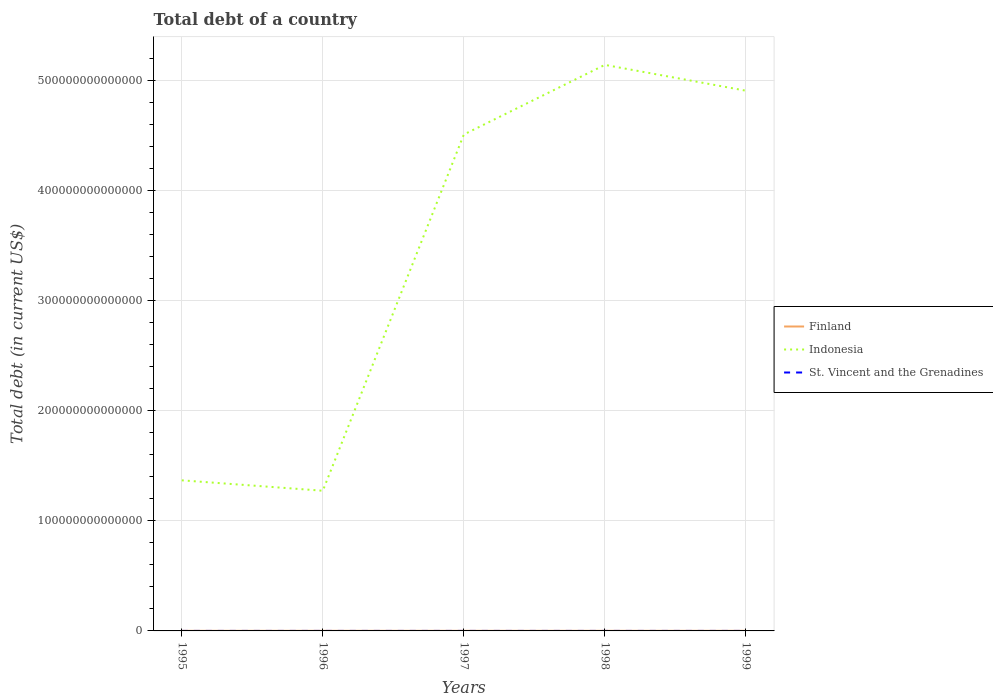How many different coloured lines are there?
Provide a short and direct response. 3. Does the line corresponding to Indonesia intersect with the line corresponding to St. Vincent and the Grenadines?
Make the answer very short. No. Is the number of lines equal to the number of legend labels?
Your answer should be compact. Yes. Across all years, what is the maximum debt in St. Vincent and the Grenadines?
Make the answer very short. 3.70e+08. In which year was the debt in Indonesia maximum?
Your answer should be compact. 1996. What is the total debt in Finland in the graph?
Offer a terse response. 4.78e+09. What is the difference between the highest and the second highest debt in Finland?
Keep it short and to the point. 1.56e+1. How many lines are there?
Your answer should be compact. 3. What is the difference between two consecutive major ticks on the Y-axis?
Offer a terse response. 1.00e+14. Are the values on the major ticks of Y-axis written in scientific E-notation?
Make the answer very short. No. Does the graph contain any zero values?
Make the answer very short. No. How many legend labels are there?
Provide a succinct answer. 3. What is the title of the graph?
Offer a very short reply. Total debt of a country. What is the label or title of the X-axis?
Give a very brief answer. Years. What is the label or title of the Y-axis?
Your answer should be compact. Total debt (in current US$). What is the Total debt (in current US$) in Finland in 1995?
Give a very brief answer. 7.43e+1. What is the Total debt (in current US$) in Indonesia in 1995?
Give a very brief answer. 1.37e+14. What is the Total debt (in current US$) of St. Vincent and the Grenadines in 1995?
Your response must be concise. 3.70e+08. What is the Total debt (in current US$) in Finland in 1996?
Your answer should be compact. 8.19e+1. What is the Total debt (in current US$) of Indonesia in 1996?
Your answer should be compact. 1.27e+14. What is the Total debt (in current US$) in St. Vincent and the Grenadines in 1996?
Keep it short and to the point. 3.72e+08. What is the Total debt (in current US$) in Finland in 1997?
Keep it short and to the point. 8.60e+1. What is the Total debt (in current US$) in Indonesia in 1997?
Your response must be concise. 4.51e+14. What is the Total debt (in current US$) in St. Vincent and the Grenadines in 1997?
Offer a terse response. 3.70e+08. What is the Total debt (in current US$) in Finland in 1998?
Give a very brief answer. 8.99e+1. What is the Total debt (in current US$) in Indonesia in 1998?
Your answer should be compact. 5.14e+14. What is the Total debt (in current US$) in St. Vincent and the Grenadines in 1998?
Offer a very short reply. 4.04e+08. What is the Total debt (in current US$) of Finland in 1999?
Your answer should be compact. 8.12e+1. What is the Total debt (in current US$) in Indonesia in 1999?
Provide a short and direct response. 4.91e+14. What is the Total debt (in current US$) of St. Vincent and the Grenadines in 1999?
Provide a succinct answer. 5.48e+08. Across all years, what is the maximum Total debt (in current US$) in Finland?
Your answer should be very brief. 8.99e+1. Across all years, what is the maximum Total debt (in current US$) of Indonesia?
Provide a succinct answer. 5.14e+14. Across all years, what is the maximum Total debt (in current US$) of St. Vincent and the Grenadines?
Offer a very short reply. 5.48e+08. Across all years, what is the minimum Total debt (in current US$) of Finland?
Your response must be concise. 7.43e+1. Across all years, what is the minimum Total debt (in current US$) in Indonesia?
Make the answer very short. 1.27e+14. Across all years, what is the minimum Total debt (in current US$) in St. Vincent and the Grenadines?
Provide a short and direct response. 3.70e+08. What is the total Total debt (in current US$) in Finland in the graph?
Your response must be concise. 4.13e+11. What is the total Total debt (in current US$) of Indonesia in the graph?
Provide a succinct answer. 1.72e+15. What is the total Total debt (in current US$) of St. Vincent and the Grenadines in the graph?
Keep it short and to the point. 2.06e+09. What is the difference between the Total debt (in current US$) of Finland in 1995 and that in 1996?
Provide a succinct answer. -7.61e+09. What is the difference between the Total debt (in current US$) of Indonesia in 1995 and that in 1996?
Your answer should be very brief. 9.46e+12. What is the difference between the Total debt (in current US$) in St. Vincent and the Grenadines in 1995 and that in 1996?
Your response must be concise. -2.50e+06. What is the difference between the Total debt (in current US$) of Finland in 1995 and that in 1997?
Make the answer very short. -1.17e+1. What is the difference between the Total debt (in current US$) of Indonesia in 1995 and that in 1997?
Provide a short and direct response. -3.14e+14. What is the difference between the Total debt (in current US$) in Finland in 1995 and that in 1998?
Your answer should be compact. -1.56e+1. What is the difference between the Total debt (in current US$) in Indonesia in 1995 and that in 1998?
Offer a terse response. -3.77e+14. What is the difference between the Total debt (in current US$) of St. Vincent and the Grenadines in 1995 and that in 1998?
Make the answer very short. -3.40e+07. What is the difference between the Total debt (in current US$) in Finland in 1995 and that in 1999?
Your response must be concise. -6.92e+09. What is the difference between the Total debt (in current US$) in Indonesia in 1995 and that in 1999?
Make the answer very short. -3.54e+14. What is the difference between the Total debt (in current US$) of St. Vincent and the Grenadines in 1995 and that in 1999?
Provide a short and direct response. -1.78e+08. What is the difference between the Total debt (in current US$) of Finland in 1996 and that in 1997?
Provide a short and direct response. -4.09e+09. What is the difference between the Total debt (in current US$) in Indonesia in 1996 and that in 1997?
Your response must be concise. -3.24e+14. What is the difference between the Total debt (in current US$) of St. Vincent and the Grenadines in 1996 and that in 1997?
Give a very brief answer. 2.60e+06. What is the difference between the Total debt (in current US$) in Finland in 1996 and that in 1998?
Provide a short and direct response. -7.96e+09. What is the difference between the Total debt (in current US$) in Indonesia in 1996 and that in 1998?
Provide a short and direct response. -3.87e+14. What is the difference between the Total debt (in current US$) in St. Vincent and the Grenadines in 1996 and that in 1998?
Offer a terse response. -3.15e+07. What is the difference between the Total debt (in current US$) in Finland in 1996 and that in 1999?
Keep it short and to the point. 6.82e+08. What is the difference between the Total debt (in current US$) in Indonesia in 1996 and that in 1999?
Your answer should be compact. -3.63e+14. What is the difference between the Total debt (in current US$) of St. Vincent and the Grenadines in 1996 and that in 1999?
Your answer should be very brief. -1.76e+08. What is the difference between the Total debt (in current US$) of Finland in 1997 and that in 1998?
Your answer should be compact. -3.86e+09. What is the difference between the Total debt (in current US$) in Indonesia in 1997 and that in 1998?
Offer a very short reply. -6.32e+13. What is the difference between the Total debt (in current US$) in St. Vincent and the Grenadines in 1997 and that in 1998?
Provide a succinct answer. -3.41e+07. What is the difference between the Total debt (in current US$) of Finland in 1997 and that in 1999?
Provide a succinct answer. 4.78e+09. What is the difference between the Total debt (in current US$) in Indonesia in 1997 and that in 1999?
Your response must be concise. -3.98e+13. What is the difference between the Total debt (in current US$) in St. Vincent and the Grenadines in 1997 and that in 1999?
Keep it short and to the point. -1.78e+08. What is the difference between the Total debt (in current US$) of Finland in 1998 and that in 1999?
Your answer should be very brief. 8.64e+09. What is the difference between the Total debt (in current US$) in Indonesia in 1998 and that in 1999?
Give a very brief answer. 2.34e+13. What is the difference between the Total debt (in current US$) of St. Vincent and the Grenadines in 1998 and that in 1999?
Your answer should be compact. -1.44e+08. What is the difference between the Total debt (in current US$) of Finland in 1995 and the Total debt (in current US$) of Indonesia in 1996?
Keep it short and to the point. -1.27e+14. What is the difference between the Total debt (in current US$) of Finland in 1995 and the Total debt (in current US$) of St. Vincent and the Grenadines in 1996?
Keep it short and to the point. 7.39e+1. What is the difference between the Total debt (in current US$) of Indonesia in 1995 and the Total debt (in current US$) of St. Vincent and the Grenadines in 1996?
Keep it short and to the point. 1.37e+14. What is the difference between the Total debt (in current US$) of Finland in 1995 and the Total debt (in current US$) of Indonesia in 1997?
Make the answer very short. -4.51e+14. What is the difference between the Total debt (in current US$) of Finland in 1995 and the Total debt (in current US$) of St. Vincent and the Grenadines in 1997?
Your answer should be very brief. 7.39e+1. What is the difference between the Total debt (in current US$) of Indonesia in 1995 and the Total debt (in current US$) of St. Vincent and the Grenadines in 1997?
Ensure brevity in your answer.  1.37e+14. What is the difference between the Total debt (in current US$) in Finland in 1995 and the Total debt (in current US$) in Indonesia in 1998?
Your answer should be very brief. -5.14e+14. What is the difference between the Total debt (in current US$) of Finland in 1995 and the Total debt (in current US$) of St. Vincent and the Grenadines in 1998?
Provide a succinct answer. 7.39e+1. What is the difference between the Total debt (in current US$) in Indonesia in 1995 and the Total debt (in current US$) in St. Vincent and the Grenadines in 1998?
Make the answer very short. 1.37e+14. What is the difference between the Total debt (in current US$) in Finland in 1995 and the Total debt (in current US$) in Indonesia in 1999?
Offer a very short reply. -4.91e+14. What is the difference between the Total debt (in current US$) in Finland in 1995 and the Total debt (in current US$) in St. Vincent and the Grenadines in 1999?
Offer a terse response. 7.38e+1. What is the difference between the Total debt (in current US$) of Indonesia in 1995 and the Total debt (in current US$) of St. Vincent and the Grenadines in 1999?
Make the answer very short. 1.37e+14. What is the difference between the Total debt (in current US$) in Finland in 1996 and the Total debt (in current US$) in Indonesia in 1997?
Offer a terse response. -4.51e+14. What is the difference between the Total debt (in current US$) in Finland in 1996 and the Total debt (in current US$) in St. Vincent and the Grenadines in 1997?
Make the answer very short. 8.15e+1. What is the difference between the Total debt (in current US$) of Indonesia in 1996 and the Total debt (in current US$) of St. Vincent and the Grenadines in 1997?
Your answer should be very brief. 1.27e+14. What is the difference between the Total debt (in current US$) of Finland in 1996 and the Total debt (in current US$) of Indonesia in 1998?
Offer a very short reply. -5.14e+14. What is the difference between the Total debt (in current US$) in Finland in 1996 and the Total debt (in current US$) in St. Vincent and the Grenadines in 1998?
Keep it short and to the point. 8.15e+1. What is the difference between the Total debt (in current US$) in Indonesia in 1996 and the Total debt (in current US$) in St. Vincent and the Grenadines in 1998?
Your response must be concise. 1.27e+14. What is the difference between the Total debt (in current US$) of Finland in 1996 and the Total debt (in current US$) of Indonesia in 1999?
Make the answer very short. -4.91e+14. What is the difference between the Total debt (in current US$) in Finland in 1996 and the Total debt (in current US$) in St. Vincent and the Grenadines in 1999?
Offer a terse response. 8.14e+1. What is the difference between the Total debt (in current US$) of Indonesia in 1996 and the Total debt (in current US$) of St. Vincent and the Grenadines in 1999?
Your answer should be compact. 1.27e+14. What is the difference between the Total debt (in current US$) in Finland in 1997 and the Total debt (in current US$) in Indonesia in 1998?
Ensure brevity in your answer.  -5.14e+14. What is the difference between the Total debt (in current US$) in Finland in 1997 and the Total debt (in current US$) in St. Vincent and the Grenadines in 1998?
Offer a terse response. 8.56e+1. What is the difference between the Total debt (in current US$) of Indonesia in 1997 and the Total debt (in current US$) of St. Vincent and the Grenadines in 1998?
Ensure brevity in your answer.  4.51e+14. What is the difference between the Total debt (in current US$) of Finland in 1997 and the Total debt (in current US$) of Indonesia in 1999?
Give a very brief answer. -4.91e+14. What is the difference between the Total debt (in current US$) of Finland in 1997 and the Total debt (in current US$) of St. Vincent and the Grenadines in 1999?
Make the answer very short. 8.55e+1. What is the difference between the Total debt (in current US$) in Indonesia in 1997 and the Total debt (in current US$) in St. Vincent and the Grenadines in 1999?
Provide a short and direct response. 4.51e+14. What is the difference between the Total debt (in current US$) in Finland in 1998 and the Total debt (in current US$) in Indonesia in 1999?
Provide a short and direct response. -4.91e+14. What is the difference between the Total debt (in current US$) of Finland in 1998 and the Total debt (in current US$) of St. Vincent and the Grenadines in 1999?
Provide a short and direct response. 8.93e+1. What is the difference between the Total debt (in current US$) in Indonesia in 1998 and the Total debt (in current US$) in St. Vincent and the Grenadines in 1999?
Give a very brief answer. 5.14e+14. What is the average Total debt (in current US$) in Finland per year?
Keep it short and to the point. 8.27e+1. What is the average Total debt (in current US$) in Indonesia per year?
Ensure brevity in your answer.  3.44e+14. What is the average Total debt (in current US$) of St. Vincent and the Grenadines per year?
Your response must be concise. 4.13e+08. In the year 1995, what is the difference between the Total debt (in current US$) of Finland and Total debt (in current US$) of Indonesia?
Your answer should be compact. -1.37e+14. In the year 1995, what is the difference between the Total debt (in current US$) in Finland and Total debt (in current US$) in St. Vincent and the Grenadines?
Offer a terse response. 7.39e+1. In the year 1995, what is the difference between the Total debt (in current US$) in Indonesia and Total debt (in current US$) in St. Vincent and the Grenadines?
Offer a terse response. 1.37e+14. In the year 1996, what is the difference between the Total debt (in current US$) in Finland and Total debt (in current US$) in Indonesia?
Your answer should be very brief. -1.27e+14. In the year 1996, what is the difference between the Total debt (in current US$) of Finland and Total debt (in current US$) of St. Vincent and the Grenadines?
Provide a short and direct response. 8.15e+1. In the year 1996, what is the difference between the Total debt (in current US$) in Indonesia and Total debt (in current US$) in St. Vincent and the Grenadines?
Keep it short and to the point. 1.27e+14. In the year 1997, what is the difference between the Total debt (in current US$) in Finland and Total debt (in current US$) in Indonesia?
Give a very brief answer. -4.51e+14. In the year 1997, what is the difference between the Total debt (in current US$) in Finland and Total debt (in current US$) in St. Vincent and the Grenadines?
Your answer should be compact. 8.56e+1. In the year 1997, what is the difference between the Total debt (in current US$) of Indonesia and Total debt (in current US$) of St. Vincent and the Grenadines?
Keep it short and to the point. 4.51e+14. In the year 1998, what is the difference between the Total debt (in current US$) in Finland and Total debt (in current US$) in Indonesia?
Your answer should be compact. -5.14e+14. In the year 1998, what is the difference between the Total debt (in current US$) of Finland and Total debt (in current US$) of St. Vincent and the Grenadines?
Offer a terse response. 8.95e+1. In the year 1998, what is the difference between the Total debt (in current US$) in Indonesia and Total debt (in current US$) in St. Vincent and the Grenadines?
Provide a short and direct response. 5.14e+14. In the year 1999, what is the difference between the Total debt (in current US$) in Finland and Total debt (in current US$) in Indonesia?
Your answer should be very brief. -4.91e+14. In the year 1999, what is the difference between the Total debt (in current US$) of Finland and Total debt (in current US$) of St. Vincent and the Grenadines?
Provide a succinct answer. 8.07e+1. In the year 1999, what is the difference between the Total debt (in current US$) in Indonesia and Total debt (in current US$) in St. Vincent and the Grenadines?
Offer a terse response. 4.91e+14. What is the ratio of the Total debt (in current US$) in Finland in 1995 to that in 1996?
Provide a short and direct response. 0.91. What is the ratio of the Total debt (in current US$) of Indonesia in 1995 to that in 1996?
Provide a succinct answer. 1.07. What is the ratio of the Total debt (in current US$) in St. Vincent and the Grenadines in 1995 to that in 1996?
Provide a succinct answer. 0.99. What is the ratio of the Total debt (in current US$) in Finland in 1995 to that in 1997?
Your answer should be compact. 0.86. What is the ratio of the Total debt (in current US$) of Indonesia in 1995 to that in 1997?
Make the answer very short. 0.3. What is the ratio of the Total debt (in current US$) in Finland in 1995 to that in 1998?
Keep it short and to the point. 0.83. What is the ratio of the Total debt (in current US$) of Indonesia in 1995 to that in 1998?
Your answer should be compact. 0.27. What is the ratio of the Total debt (in current US$) in St. Vincent and the Grenadines in 1995 to that in 1998?
Offer a very short reply. 0.92. What is the ratio of the Total debt (in current US$) in Finland in 1995 to that in 1999?
Make the answer very short. 0.91. What is the ratio of the Total debt (in current US$) in Indonesia in 1995 to that in 1999?
Keep it short and to the point. 0.28. What is the ratio of the Total debt (in current US$) in St. Vincent and the Grenadines in 1995 to that in 1999?
Your answer should be compact. 0.68. What is the ratio of the Total debt (in current US$) of Finland in 1996 to that in 1997?
Your answer should be compact. 0.95. What is the ratio of the Total debt (in current US$) of Indonesia in 1996 to that in 1997?
Give a very brief answer. 0.28. What is the ratio of the Total debt (in current US$) in St. Vincent and the Grenadines in 1996 to that in 1997?
Your response must be concise. 1.01. What is the ratio of the Total debt (in current US$) in Finland in 1996 to that in 1998?
Keep it short and to the point. 0.91. What is the ratio of the Total debt (in current US$) in Indonesia in 1996 to that in 1998?
Give a very brief answer. 0.25. What is the ratio of the Total debt (in current US$) of St. Vincent and the Grenadines in 1996 to that in 1998?
Provide a short and direct response. 0.92. What is the ratio of the Total debt (in current US$) in Finland in 1996 to that in 1999?
Offer a terse response. 1.01. What is the ratio of the Total debt (in current US$) in Indonesia in 1996 to that in 1999?
Your response must be concise. 0.26. What is the ratio of the Total debt (in current US$) of St. Vincent and the Grenadines in 1996 to that in 1999?
Your answer should be compact. 0.68. What is the ratio of the Total debt (in current US$) in Indonesia in 1997 to that in 1998?
Ensure brevity in your answer.  0.88. What is the ratio of the Total debt (in current US$) of St. Vincent and the Grenadines in 1997 to that in 1998?
Provide a succinct answer. 0.92. What is the ratio of the Total debt (in current US$) of Finland in 1997 to that in 1999?
Your response must be concise. 1.06. What is the ratio of the Total debt (in current US$) in Indonesia in 1997 to that in 1999?
Make the answer very short. 0.92. What is the ratio of the Total debt (in current US$) of St. Vincent and the Grenadines in 1997 to that in 1999?
Make the answer very short. 0.67. What is the ratio of the Total debt (in current US$) in Finland in 1998 to that in 1999?
Your answer should be very brief. 1.11. What is the ratio of the Total debt (in current US$) in Indonesia in 1998 to that in 1999?
Provide a short and direct response. 1.05. What is the ratio of the Total debt (in current US$) in St. Vincent and the Grenadines in 1998 to that in 1999?
Provide a succinct answer. 0.74. What is the difference between the highest and the second highest Total debt (in current US$) in Finland?
Provide a short and direct response. 3.86e+09. What is the difference between the highest and the second highest Total debt (in current US$) of Indonesia?
Make the answer very short. 2.34e+13. What is the difference between the highest and the second highest Total debt (in current US$) in St. Vincent and the Grenadines?
Provide a short and direct response. 1.44e+08. What is the difference between the highest and the lowest Total debt (in current US$) in Finland?
Provide a short and direct response. 1.56e+1. What is the difference between the highest and the lowest Total debt (in current US$) in Indonesia?
Keep it short and to the point. 3.87e+14. What is the difference between the highest and the lowest Total debt (in current US$) of St. Vincent and the Grenadines?
Give a very brief answer. 1.78e+08. 